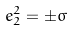<formula> <loc_0><loc_0><loc_500><loc_500>e _ { 2 } ^ { 2 } = \pm \sigma</formula> 